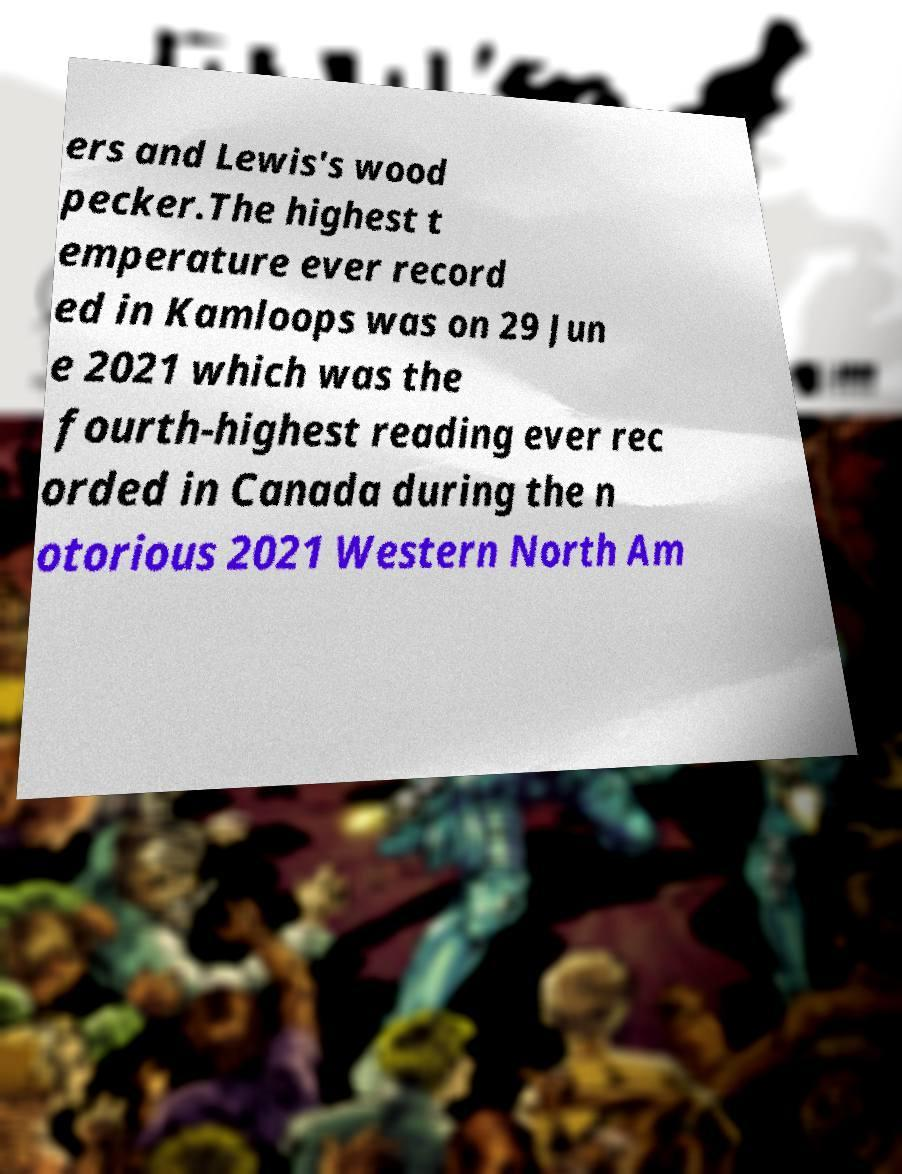For documentation purposes, I need the text within this image transcribed. Could you provide that? ers and Lewis's wood pecker.The highest t emperature ever record ed in Kamloops was on 29 Jun e 2021 which was the fourth-highest reading ever rec orded in Canada during the n otorious 2021 Western North Am 